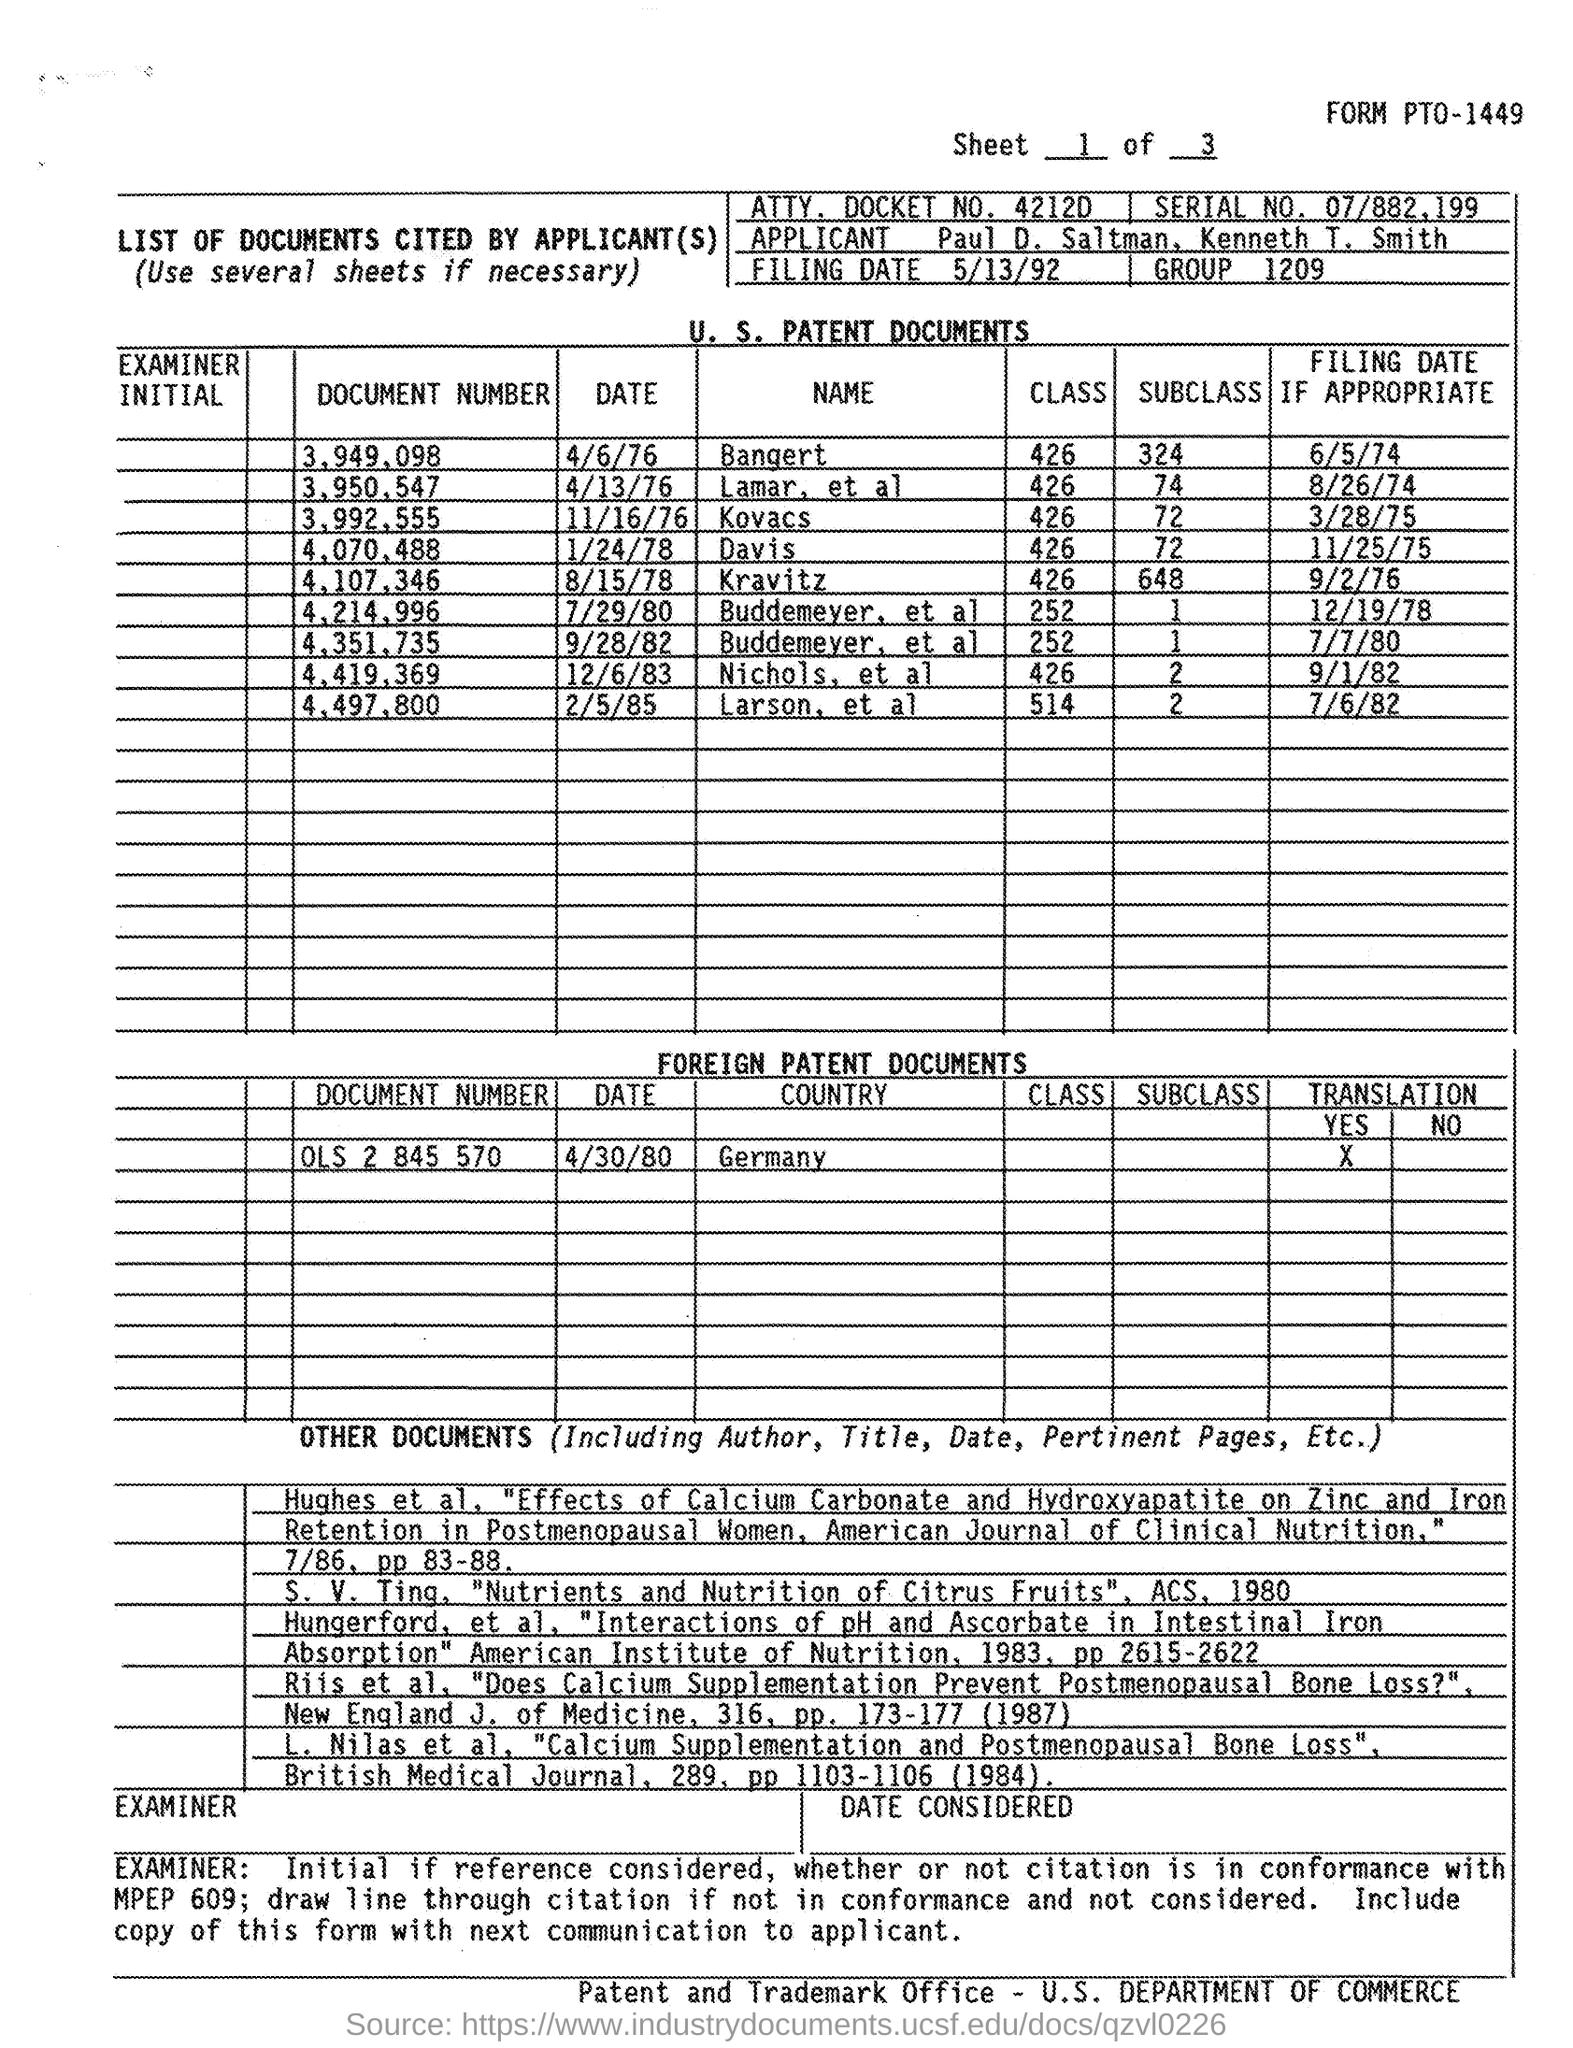Draw attention to some important aspects in this diagram. What is the document number of Kovacs given? It is 3,992,555. The filing date of document number 3,949,098, which was filed on June 5th, 1974, is known. The document number of Bangert is 3,949,098. According to the document, 426 classes are mentioned for Davis. According to the document, a total of 648 subclasses have been mentioned for Kravitz. 